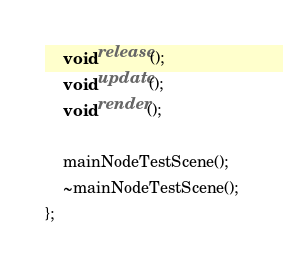<code> <loc_0><loc_0><loc_500><loc_500><_C_>	void release();
	void update();
	void render();

	mainNodeTestScene();
	~mainNodeTestScene();
};

</code> 